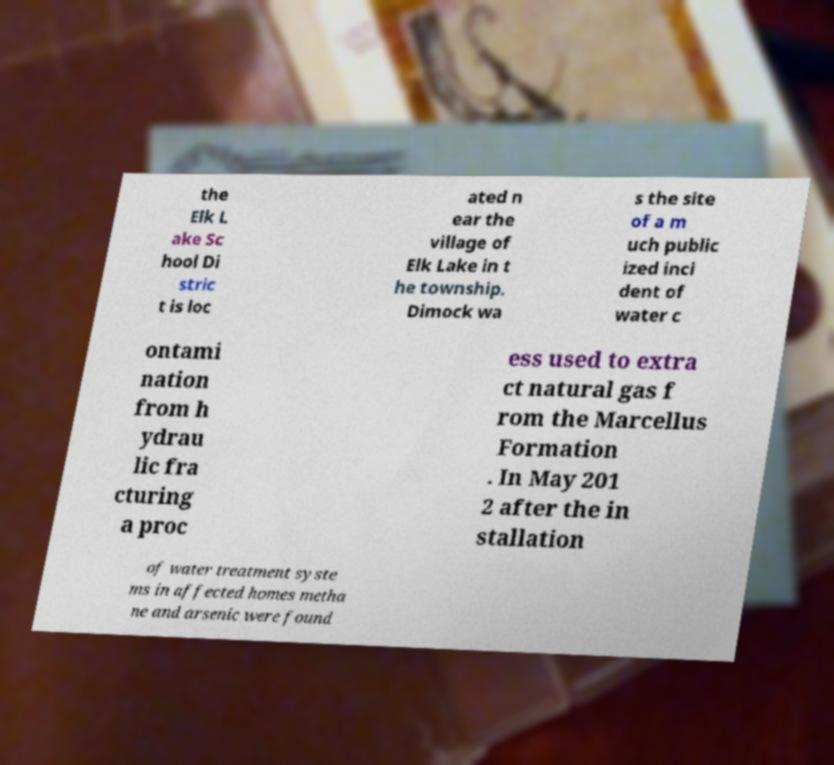Can you accurately transcribe the text from the provided image for me? the Elk L ake Sc hool Di stric t is loc ated n ear the village of Elk Lake in t he township. Dimock wa s the site of a m uch public ized inci dent of water c ontami nation from h ydrau lic fra cturing a proc ess used to extra ct natural gas f rom the Marcellus Formation . In May 201 2 after the in stallation of water treatment syste ms in affected homes metha ne and arsenic were found 